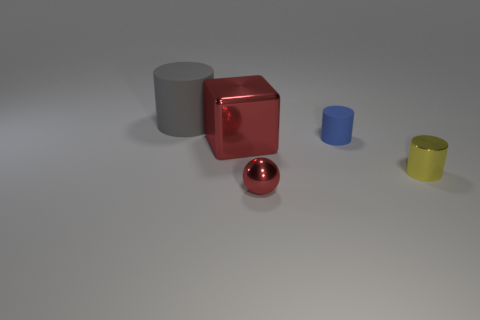What could be the purpose of this arrangement of objects? This arrangement of objects could serve various purposes, such as an exercise in 3D rendering to illustrate texture, lighting effects, and the play of shadows. Alternatively, it may represent a conceptual art piece designed to evoke a response or to illustrate principles of geometry and space. 